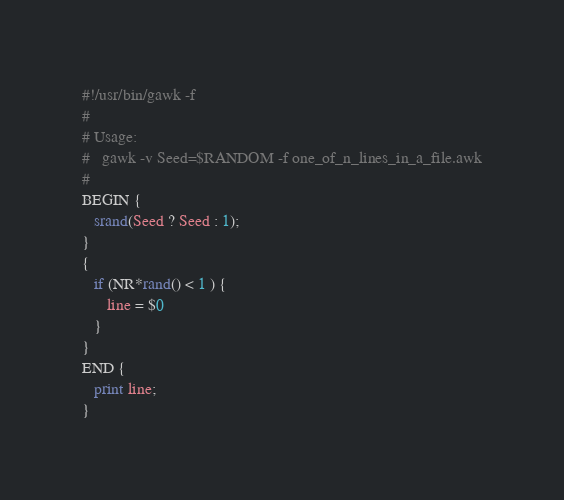Convert code to text. <code><loc_0><loc_0><loc_500><loc_500><_Awk_>#!/usr/bin/gawk -f
#
# Usage:
#   gawk -v Seed=$RANDOM -f one_of_n_lines_in_a_file.awk
#
BEGIN {
   srand(Seed ? Seed : 1);
}
{
   if (NR*rand() < 1 ) {
      line = $0
   }
}
END {
   print line;
}
</code> 